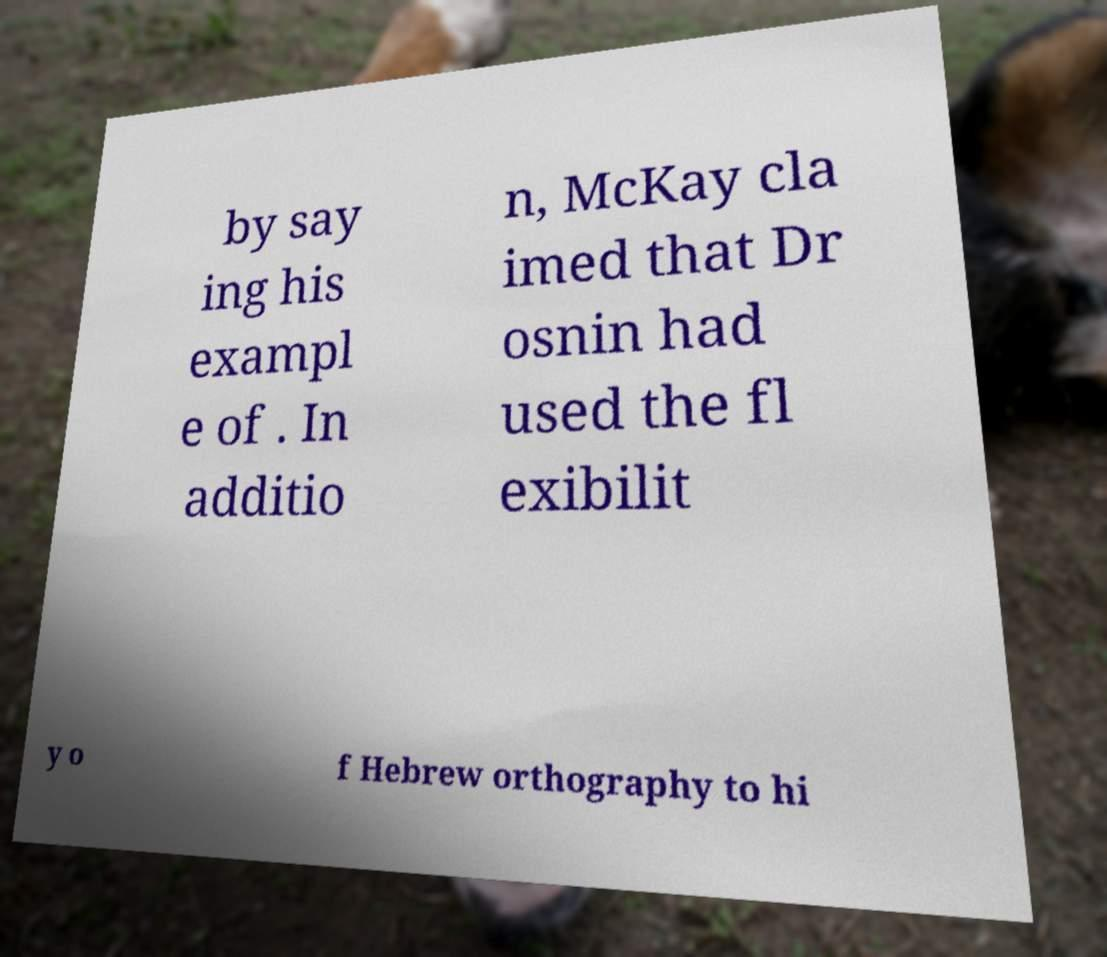Please read and relay the text visible in this image. What does it say? by say ing his exampl e of . In additio n, McKay cla imed that Dr osnin had used the fl exibilit y o f Hebrew orthography to hi 